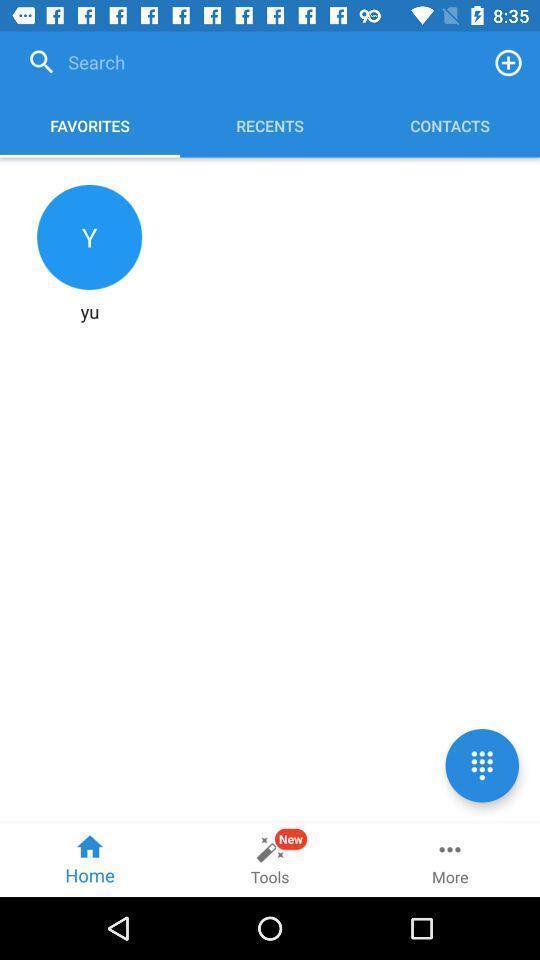Describe the content in this image. Search bar to find favorites contacts. Please provide a description for this image. Screen page displaying various options in call application. 